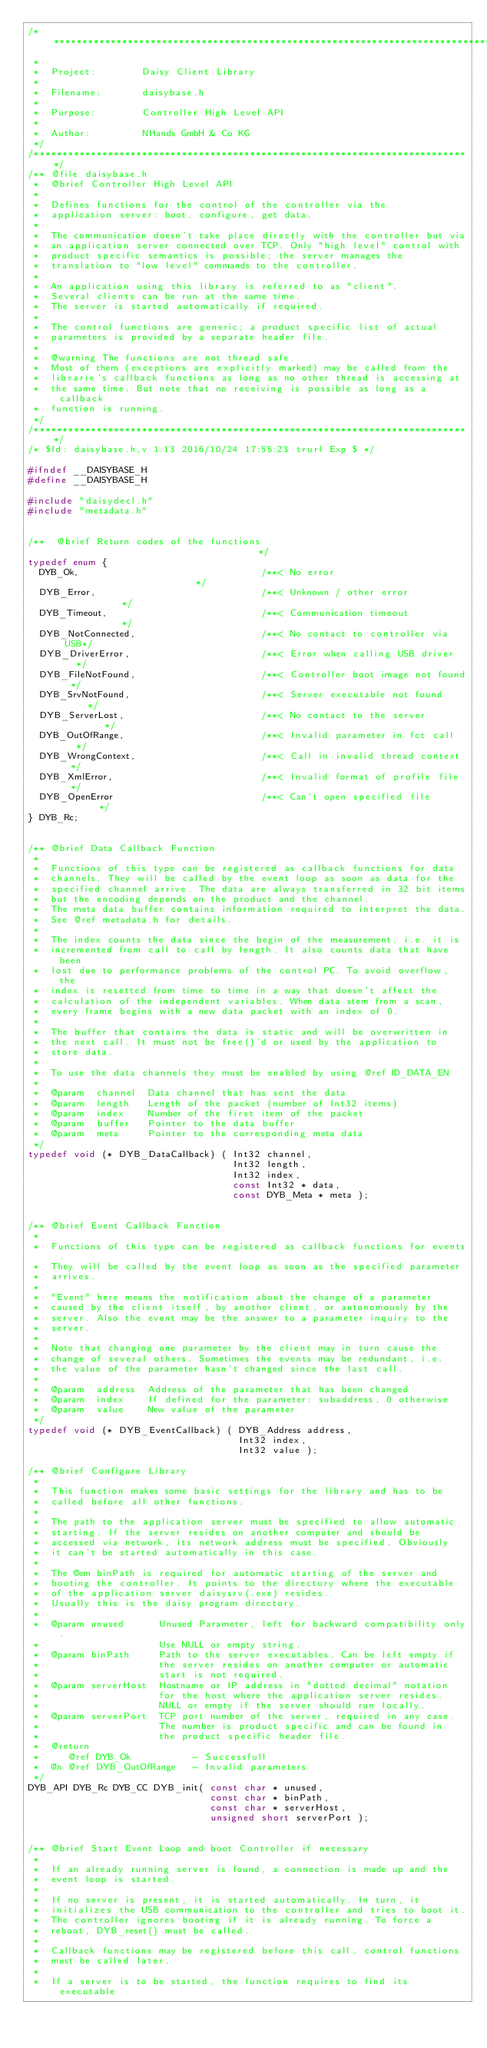Convert code to text. <code><loc_0><loc_0><loc_500><loc_500><_C_>/******************************************************************************
 *
 *  Project:        Daisy Client Library
 *
 *  Filename:       daisybase.h
 *
 *  Purpose:        Controller High Level API
 *
 *  Author:         NHands GmbH & Co KG
 */
/*****************************************************************************/
/** @file daisybase.h
 *  @brief Controller High Level API
 *
 *  Defines functions for the control of the controller via the
 *  application server: boot, configure, get data.
 *
 *  The communication doesn't take place directly with the controller but via
 *  an application server connected over TCP. Only "high level" control with
 *  product specific semantics is possible; the server manages the
 *  translation to "low level" commands to the controller.
 *
 *  An application using this library is referred to as "client".
 *  Several clients can be run at the same time.
 *  The server is started automatically if required.
 *
 *  The control functions are generic; a product specific list of actual
 *  parameters is provided by a separate header file.
 *
 *  @warning The functions are not thread safe.
 *  Most of them (exceptions are explicitly marked) may be called from the
 *  librarie's callback functions as long as no other thread is accessing at
 *  the same time. But note that no receiving is possible as long as a callback
 *  function is running.
 */
/*****************************************************************************/
/* $Id: daisybase.h,v 1.13 2016/10/24 17:55:23 trurl Exp $ */

#ifndef __DAISYBASE_H
#define __DAISYBASE_H

#include "daisydecl.h"
#include "metadata.h"


/**  @brief Return codes of the functions                                     */
typedef enum {
  DYB_Ok,                                /**< No error                        */
  DYB_Error,                             /**< Unknown / other error           */
  DYB_Timeout,                           /**< Communication timeout           */
  DYB_NotConnected,                      /**< No contact to controller via USB*/
  DYB_DriverError,                       /**< Error when calling USB driver   */
  DYB_FileNotFound,                      /**< Controller boot image not found */
  DYB_SrvNotFound,                       /**< Server executable not found     */
  DYB_ServerLost,                        /**< No contact to the server        */
  DYB_OutOfRange,                        /**< Invalid parameter in fct call   */
  DYB_WrongContext,                      /**< Call in invalid thread context  */
  DYB_XmlError,                          /**< Invalid format of profile file  */
  DYB_OpenError                          /**< Can't open specified file       */
} DYB_Rc;


/** @brief Data Callback Function
 *
 *  Functions of this type can be registered as callback functions for data
 *  channels. They will be called by the event loop as soon as data for the
 *  specified channel arrive. The data are always transferred in 32 bit items
 *  but the encoding depends on the product and the channel.
 *  The meta data buffer contains information required to interpret the data.
 *  See @ref metadata.h for details.
 *
 *  The index counts the data since the begin of the measurement, i.e. it is
 *  incremented from call to call by length. It also counts data that have been
 *  lost due to performance problems of the control PC. To avoid overflow, the
 *  index is resetted from time to time in a way that doesn't affect the
 *  calculation of the independent variables. When data stem from a scan,
 *  every frame begins with a new data packet with an index of 0.
 *
 *  The buffer that contains the data is static and will be overwritten in
 *  the next call. It must not be free()'d or used by the application to
 *  store data.
 * 
 *  To use the data channels they must be enabled by using @ref ID_DATA_EN
 *
 *  @param  channel  Data channel that has sent the data
 *  @param  length   Length of the packet (number of Int32 items)
 *  @param  index    Number of the first item of the packet
 *  @param  buffer   Pointer to the data buffer
 *  @param  meta     Pointer to the corresponding meta data
 */
typedef void (* DYB_DataCallback) ( Int32 channel,
                                    Int32 length,
                                    Int32 index,
                                    const Int32 * data,
                                    const DYB_Meta * meta );


/** @brief Event Callback Function
 *
 *  Functions of this type can be registered as callback functions for events.
 *  They will be called by the event loop as soon as the specified parameter
 *  arrives.
 *
 *  "Event" here means the notification about the change of a parameter
 *  caused by the client itself, by another client, or autonomously by the
 *  server. Also the event may be the answer to a parameter inquiry to the
 *  server.
 *
 *  Note that changing one parameter by the client may in turn cause the
 *  change of several others. Sometimes the events may be redundant, i.e.
 *  the value of the parameter hasn't changed since the last call.
 *
 *  @param  address  Address of the parameter that has been changed
 *  @param  index    If defined for the parameter: subaddress, 0 otherwise
 *  @param  value    New value of the parameter
 */
typedef void (* DYB_EventCallback) ( DYB_Address address,
                                     Int32 index,
                                     Int32 value );

/** @brief Configure Library
 *
 *  This function makes some basic settings for the library and has to be
 *  called before all other functions.
 *
 *  The path to the application server must be specified to allow automatic
 *  starting. If the server resides on another computer and should be
 *  accessed via network, its network address must be specified. Obviously
 *  it can't be started automatically in this case.
 *
 *  The @em binPath is required for automatic starting of the server and
 *  booting the controller. It points to the directory where the executable
 *  of the application server daisysrv(.exe) resides.
 *  Usually this is the daisy program directory.
 *
 *  @param unused      Unused Parameter, left for backward compatibility only.
 *                     Use NULL or empty string.
 *  @param binPath     Path to the server executables. Can be left empty if
 *                     the server resides on another computer or automatic
 *                     start is not required.
 *  @param serverHost  Hostname or IP address in "dotted decimal" notation
 *                     for the host where the application server resides.
 *                     NULL or empty if the server should run locally.
 *  @param serverPort  TCP port number of the server, required in any case.
 *                     The number is product specific and can be found in
 *                     the product specific header file.
 *  @return
 *     @ref DYB_Ok           - Successfull
 *  @n @ref DYB_OutOfRange   - Invalid parameters
 */
DYB_API DYB_Rc DYB_CC DYB_init( const char * unused,
                                const char * binPath,
                                const char * serverHost,
                                unsigned short serverPort );


/** @brief Start Event Loop and boot Controller if necessary
 *
 *  If an already running server is found, a connection is made up and the
 *  event loop is started.
 *  
 *  If no server is present, it is started automatically. In turn, it
 *  initializes the USB communication to the controller and tries to boot it.
 *  The controller ignores booting if it is already running. To force a
 *  reboot, DYB_reset() must be called.
 *
 *  Callback functions may be registered before this call, control functions
 *  must be called later.
 *
 *  If a server is to be started, the function requires to find its executable</code> 